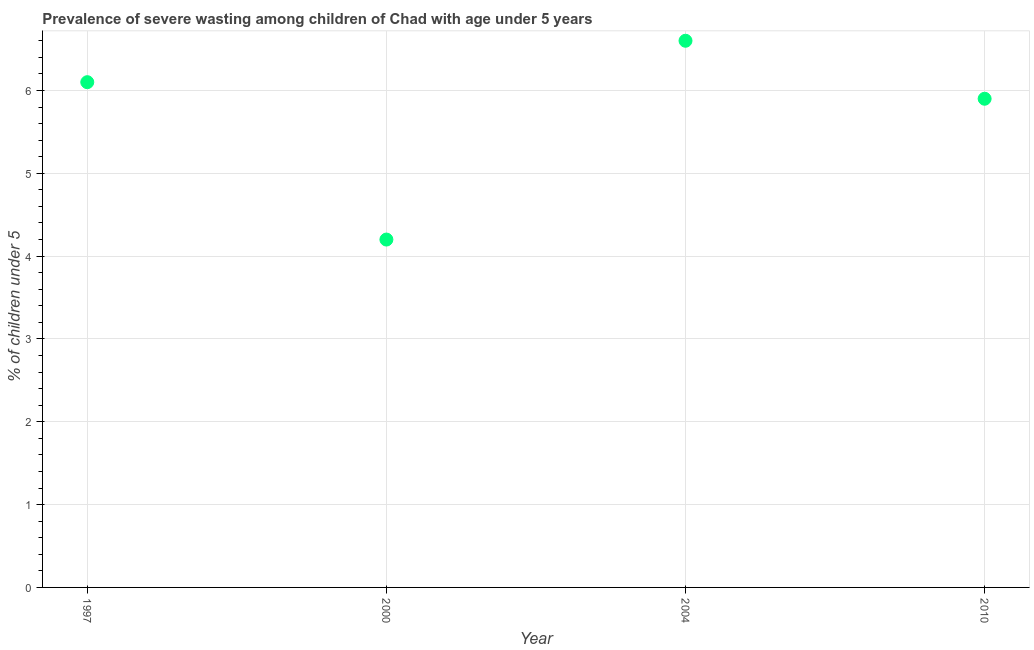What is the prevalence of severe wasting in 1997?
Keep it short and to the point. 6.1. Across all years, what is the maximum prevalence of severe wasting?
Make the answer very short. 6.6. Across all years, what is the minimum prevalence of severe wasting?
Ensure brevity in your answer.  4.2. In which year was the prevalence of severe wasting minimum?
Give a very brief answer. 2000. What is the sum of the prevalence of severe wasting?
Offer a very short reply. 22.8. What is the average prevalence of severe wasting per year?
Keep it short and to the point. 5.7. Do a majority of the years between 2010 and 2004 (inclusive) have prevalence of severe wasting greater than 5.6 %?
Keep it short and to the point. No. What is the ratio of the prevalence of severe wasting in 1997 to that in 2000?
Provide a succinct answer. 1.45. What is the difference between the highest and the second highest prevalence of severe wasting?
Give a very brief answer. 0.5. What is the difference between the highest and the lowest prevalence of severe wasting?
Give a very brief answer. 2.4. In how many years, is the prevalence of severe wasting greater than the average prevalence of severe wasting taken over all years?
Provide a succinct answer. 3. Does the prevalence of severe wasting monotonically increase over the years?
Give a very brief answer. No. How many dotlines are there?
Give a very brief answer. 1. How many years are there in the graph?
Provide a short and direct response. 4. What is the difference between two consecutive major ticks on the Y-axis?
Give a very brief answer. 1. Does the graph contain any zero values?
Provide a short and direct response. No. What is the title of the graph?
Give a very brief answer. Prevalence of severe wasting among children of Chad with age under 5 years. What is the label or title of the Y-axis?
Provide a short and direct response.  % of children under 5. What is the  % of children under 5 in 1997?
Ensure brevity in your answer.  6.1. What is the  % of children under 5 in 2000?
Your answer should be compact. 4.2. What is the  % of children under 5 in 2004?
Keep it short and to the point. 6.6. What is the  % of children under 5 in 2010?
Make the answer very short. 5.9. What is the difference between the  % of children under 5 in 1997 and 2000?
Make the answer very short. 1.9. What is the difference between the  % of children under 5 in 1997 and 2010?
Your answer should be compact. 0.2. What is the difference between the  % of children under 5 in 2000 and 2010?
Offer a terse response. -1.7. What is the difference between the  % of children under 5 in 2004 and 2010?
Your answer should be compact. 0.7. What is the ratio of the  % of children under 5 in 1997 to that in 2000?
Provide a succinct answer. 1.45. What is the ratio of the  % of children under 5 in 1997 to that in 2004?
Offer a terse response. 0.92. What is the ratio of the  % of children under 5 in 1997 to that in 2010?
Provide a short and direct response. 1.03. What is the ratio of the  % of children under 5 in 2000 to that in 2004?
Your answer should be compact. 0.64. What is the ratio of the  % of children under 5 in 2000 to that in 2010?
Provide a succinct answer. 0.71. What is the ratio of the  % of children under 5 in 2004 to that in 2010?
Offer a terse response. 1.12. 